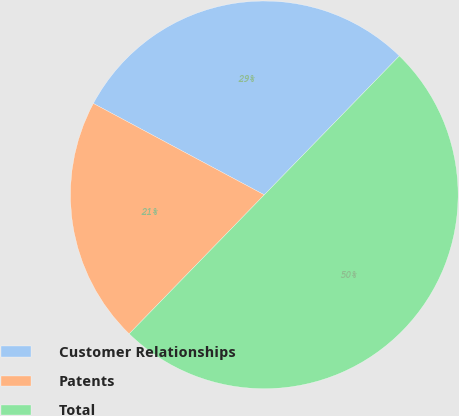Convert chart. <chart><loc_0><loc_0><loc_500><loc_500><pie_chart><fcel>Customer Relationships<fcel>Patents<fcel>Total<nl><fcel>29.46%<fcel>20.54%<fcel>50.0%<nl></chart> 